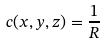Convert formula to latex. <formula><loc_0><loc_0><loc_500><loc_500>c ( x , y , z ) = \frac { 1 } { R }</formula> 